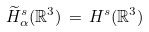Convert formula to latex. <formula><loc_0><loc_0><loc_500><loc_500>\widetilde { H } ^ { s } _ { \alpha } ( \mathbb { R } ^ { 3 } ) \, = \, H ^ { s } ( \mathbb { R } ^ { 3 } )</formula> 